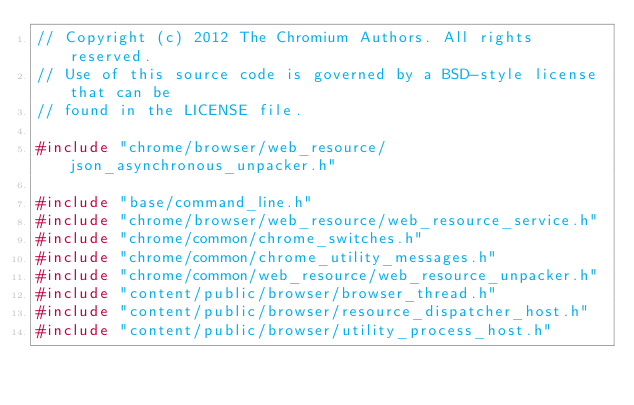<code> <loc_0><loc_0><loc_500><loc_500><_C++_>// Copyright (c) 2012 The Chromium Authors. All rights reserved.
// Use of this source code is governed by a BSD-style license that can be
// found in the LICENSE file.

#include "chrome/browser/web_resource/json_asynchronous_unpacker.h"

#include "base/command_line.h"
#include "chrome/browser/web_resource/web_resource_service.h"
#include "chrome/common/chrome_switches.h"
#include "chrome/common/chrome_utility_messages.h"
#include "chrome/common/web_resource/web_resource_unpacker.h"
#include "content/public/browser/browser_thread.h"
#include "content/public/browser/resource_dispatcher_host.h"
#include "content/public/browser/utility_process_host.h"</code> 